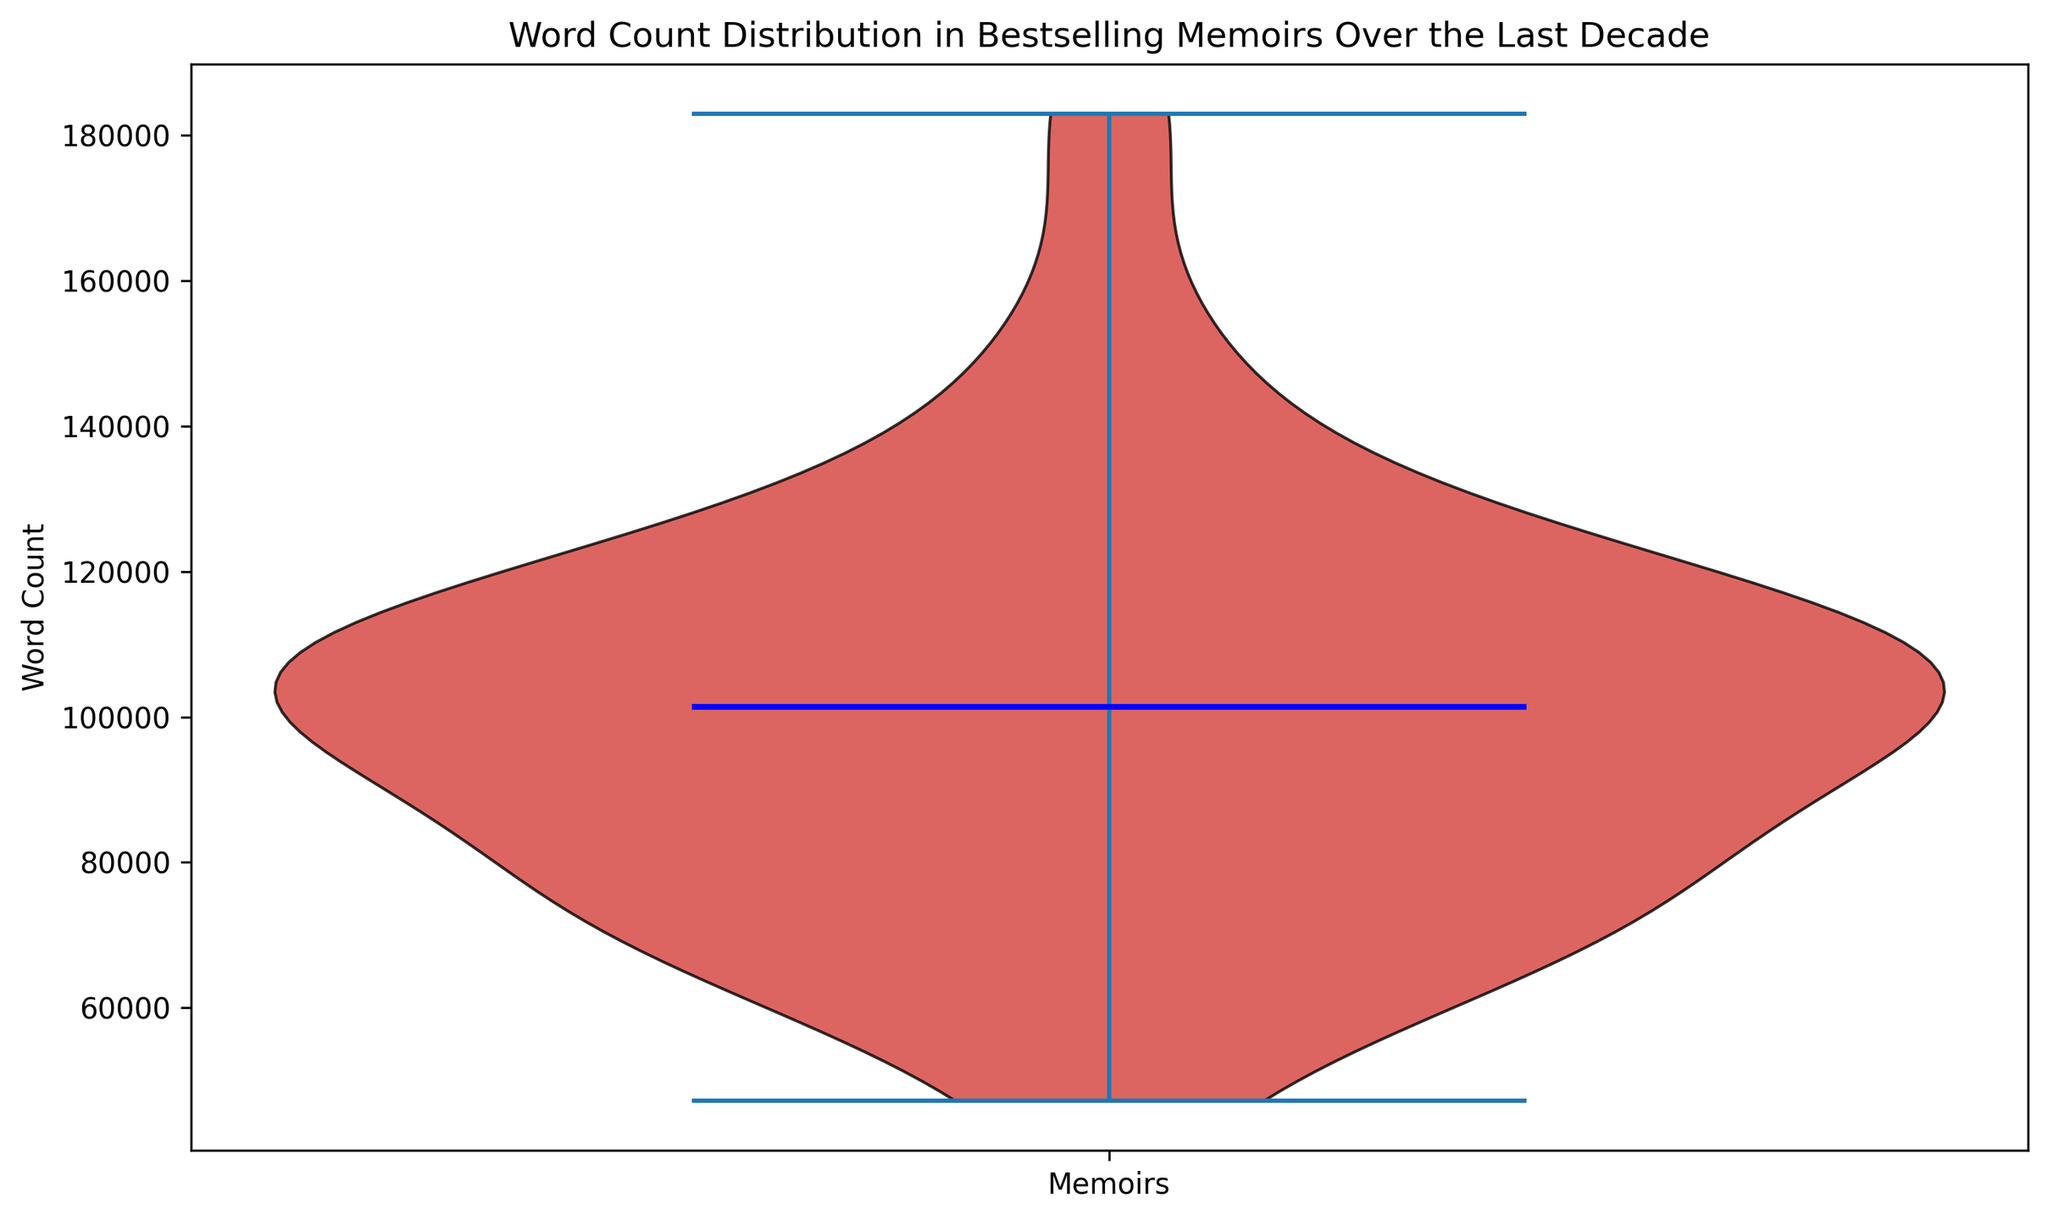What's the median word count in bestselling memoirs over the last decade? To find the median word count, look at the blue line in the center of the violin plot. This line marks the median value of the word counts.
Answer: Approximately 105,200 words Is the distribution of word counts positively skewed, negatively skewed, or symmetric? Observe the shape of the red area within the violin plot. If it's longer or extends further to the right, it is positively skewed. If it's longer to the left, it's negatively skewed. If both sides mirror each other, it's symmetric.
Answer: Slightly positively skewed Which color represents the median word count? The median line in the violin plot is a distinct color, different from the rest of the plot. Identify the color used for this line.
Answer: Blue How wide is the range of word counts in the memoirs? The width of the violin plot at its widest point gives an idea of the range of data. The ends of the plot indicate where the data starts and ends.
Answer: From around 47,200 to 183,000 words Where do most memoirs fall within the word count range? The wider parts of the violin plot show where data points are more densely concentrated. Observing these areas can help determine where most memoirs' word counts fall.
Answer: Around 90,000 to 120,000 words Are there more memoirs with higher word counts or lower word counts? Examining the density of the red area in the plot, assess whether it's more extended towards higher or lower word count regions.
Answer: More memoirs with lower word counts How does the median word count compare to the average word count? The median is shown by the blue line. To infer the average, understand the distribution shape. In a skewed distribution, the mean is pulled towards the skew. Since it's slightly positively skewed, the mean word count is likely greater than the median.
Answer: Median is less than the average What is indicated by the color of the main body of the violin plot? The shade of the main body of the violin plot represents the distribution spread of word counts.
Answer: Distribution density How does the word count of the longest memoir compare to the shortest memoir? Comparing the minimum and maximum extents of the violin plot shows the range from the shortest to the longest memoirs.
Answer: Longest (183,000 words) is much longer than the shortest (47,200 words) Is there a significant concentration of memoirs with word counts around the median? The width of the violin plot around the median indicates concentrations of data points. A wider section around the median suggests more memoirs have word counts near this value.
Answer: Yes, significant concentration around the median 